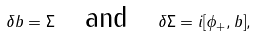<formula> <loc_0><loc_0><loc_500><loc_500>\delta b = \Sigma \quad \text {and} \quad \delta \Sigma = i [ \phi _ { + } , b ] ,</formula> 